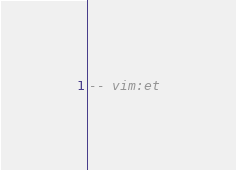Convert code to text. <code><loc_0><loc_0><loc_500><loc_500><_SQL_>-- vim:et
</code> 